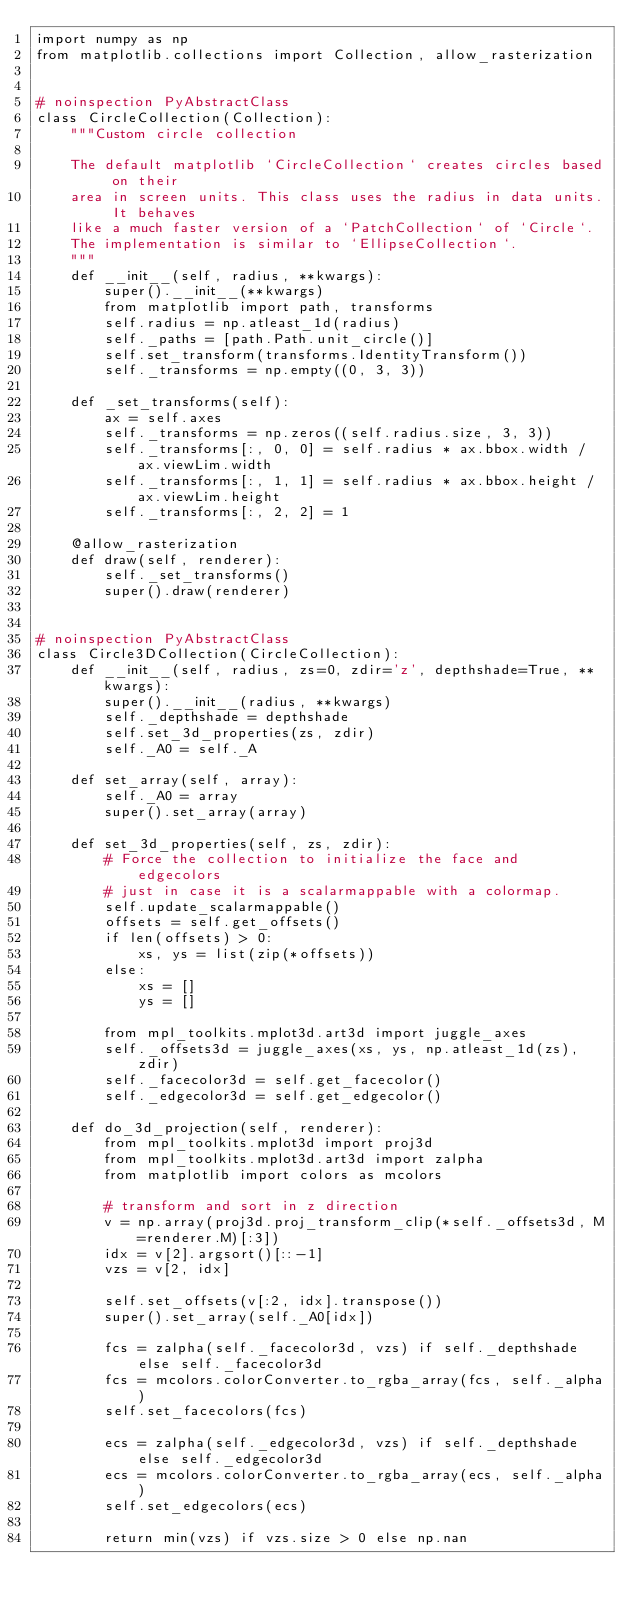<code> <loc_0><loc_0><loc_500><loc_500><_Python_>import numpy as np
from matplotlib.collections import Collection, allow_rasterization


# noinspection PyAbstractClass
class CircleCollection(Collection):
    """Custom circle collection

    The default matplotlib `CircleCollection` creates circles based on their
    area in screen units. This class uses the radius in data units. It behaves
    like a much faster version of a `PatchCollection` of `Circle`.
    The implementation is similar to `EllipseCollection`.
    """
    def __init__(self, radius, **kwargs):
        super().__init__(**kwargs)
        from matplotlib import path, transforms
        self.radius = np.atleast_1d(radius)
        self._paths = [path.Path.unit_circle()]
        self.set_transform(transforms.IdentityTransform())
        self._transforms = np.empty((0, 3, 3))

    def _set_transforms(self):
        ax = self.axes
        self._transforms = np.zeros((self.radius.size, 3, 3))
        self._transforms[:, 0, 0] = self.radius * ax.bbox.width / ax.viewLim.width
        self._transforms[:, 1, 1] = self.radius * ax.bbox.height / ax.viewLim.height
        self._transforms[:, 2, 2] = 1

    @allow_rasterization
    def draw(self, renderer):
        self._set_transforms()
        super().draw(renderer)


# noinspection PyAbstractClass
class Circle3DCollection(CircleCollection):
    def __init__(self, radius, zs=0, zdir='z', depthshade=True, **kwargs):
        super().__init__(radius, **kwargs)
        self._depthshade = depthshade
        self.set_3d_properties(zs, zdir)
        self._A0 = self._A

    def set_array(self, array):
        self._A0 = array
        super().set_array(array)

    def set_3d_properties(self, zs, zdir):
        # Force the collection to initialize the face and edgecolors
        # just in case it is a scalarmappable with a colormap.
        self.update_scalarmappable()
        offsets = self.get_offsets()
        if len(offsets) > 0:
            xs, ys = list(zip(*offsets))
        else:
            xs = []
            ys = []

        from mpl_toolkits.mplot3d.art3d import juggle_axes
        self._offsets3d = juggle_axes(xs, ys, np.atleast_1d(zs), zdir)
        self._facecolor3d = self.get_facecolor()
        self._edgecolor3d = self.get_edgecolor()

    def do_3d_projection(self, renderer):
        from mpl_toolkits.mplot3d import proj3d
        from mpl_toolkits.mplot3d.art3d import zalpha
        from matplotlib import colors as mcolors

        # transform and sort in z direction
        v = np.array(proj3d.proj_transform_clip(*self._offsets3d, M=renderer.M)[:3])
        idx = v[2].argsort()[::-1]
        vzs = v[2, idx]

        self.set_offsets(v[:2, idx].transpose())
        super().set_array(self._A0[idx])

        fcs = zalpha(self._facecolor3d, vzs) if self._depthshade else self._facecolor3d
        fcs = mcolors.colorConverter.to_rgba_array(fcs, self._alpha)
        self.set_facecolors(fcs)

        ecs = zalpha(self._edgecolor3d, vzs) if self._depthshade else self._edgecolor3d
        ecs = mcolors.colorConverter.to_rgba_array(ecs, self._alpha)
        self.set_edgecolors(ecs)

        return min(vzs) if vzs.size > 0 else np.nan
</code> 